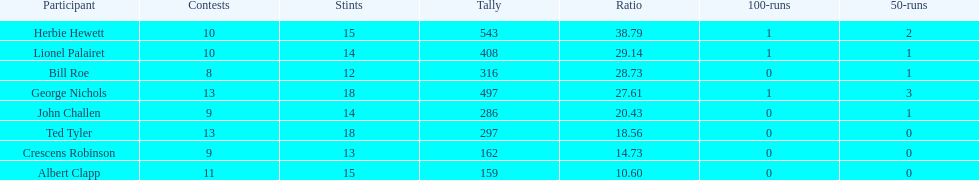What were the number of innings albert clapp had? 15. 